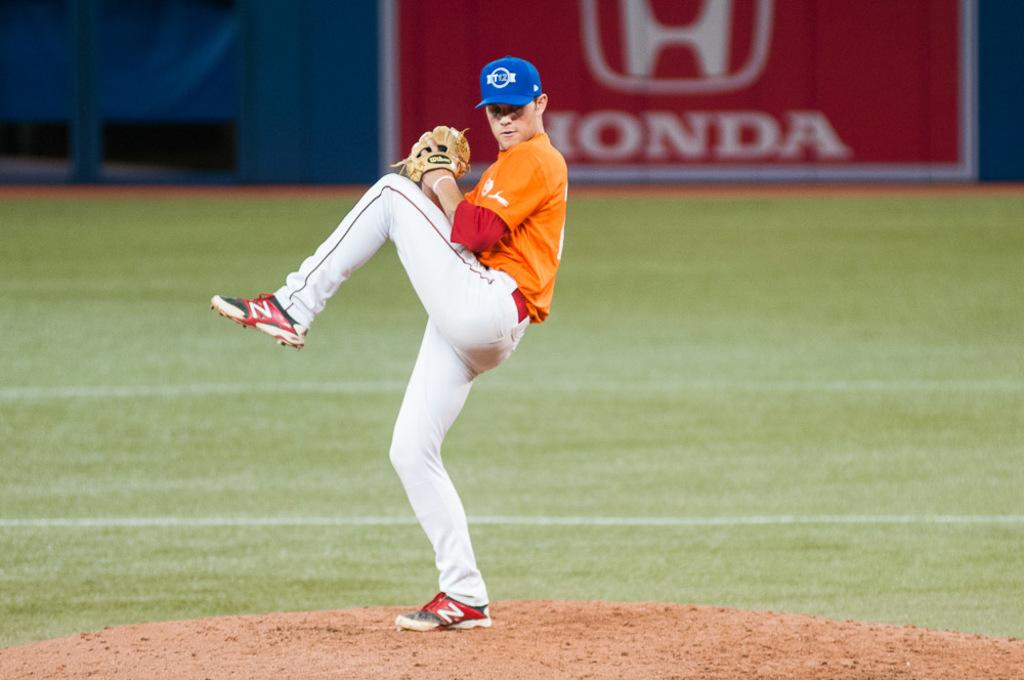<image>
Describe the image concisely. A baseball player winds up to throw the ball in front of a giant Honda advert 